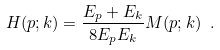<formula> <loc_0><loc_0><loc_500><loc_500>H ( p ; k ) = \frac { E _ { p } + E _ { k } } { 8 E _ { p } E _ { k } } M ( p ; k ) \ .</formula> 